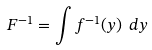Convert formula to latex. <formula><loc_0><loc_0><loc_500><loc_500>F ^ { - 1 } = \int f ^ { - 1 } ( y ) \ d y \</formula> 